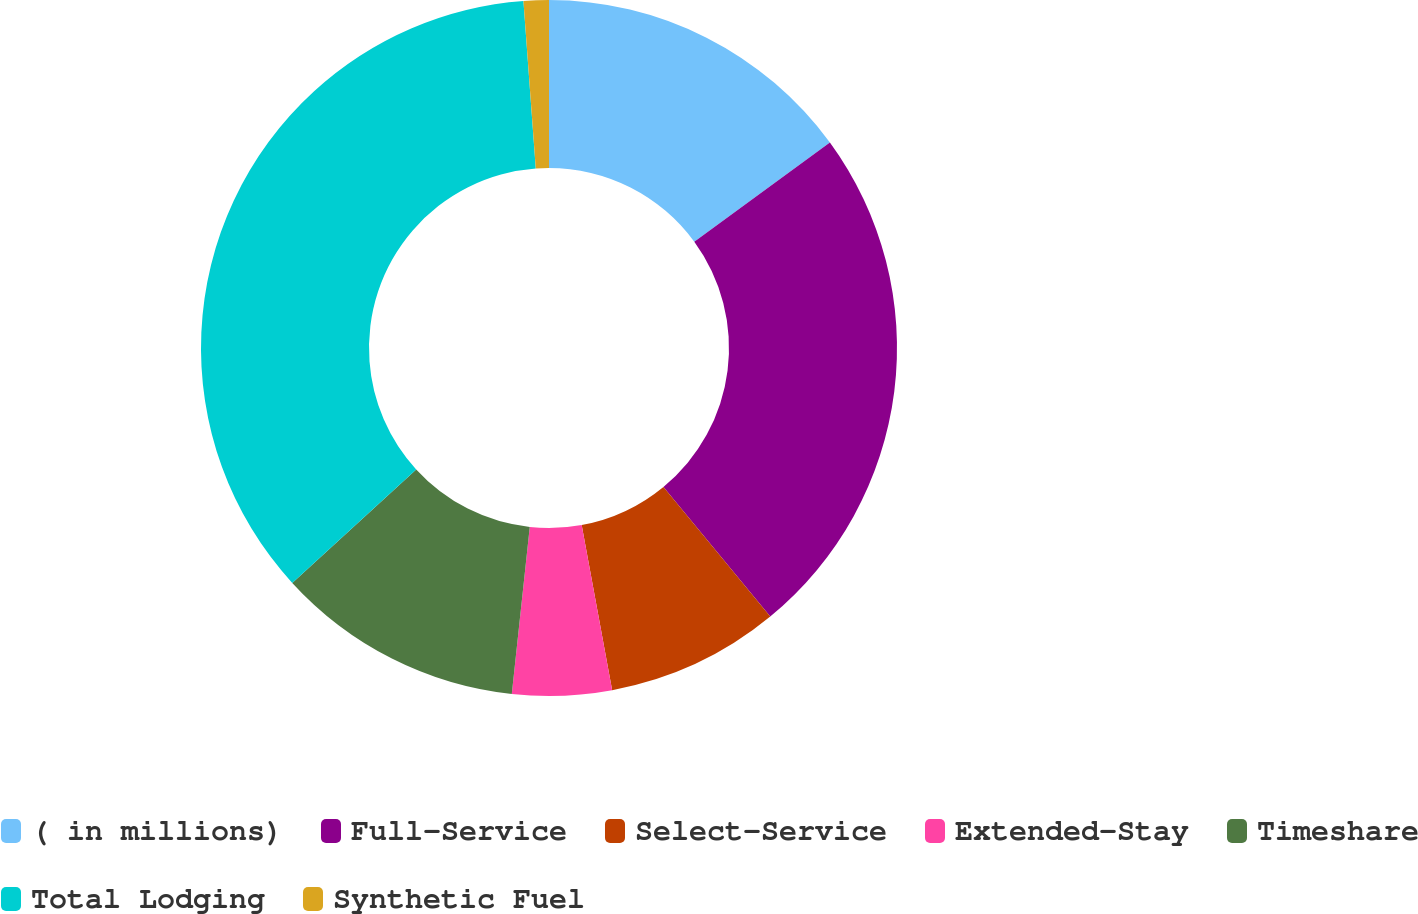Convert chart. <chart><loc_0><loc_0><loc_500><loc_500><pie_chart><fcel>( in millions)<fcel>Full-Service<fcel>Select-Service<fcel>Extended-Stay<fcel>Timeshare<fcel>Total Lodging<fcel>Synthetic Fuel<nl><fcel>14.95%<fcel>24.08%<fcel>8.06%<fcel>4.61%<fcel>11.5%<fcel>35.62%<fcel>1.17%<nl></chart> 